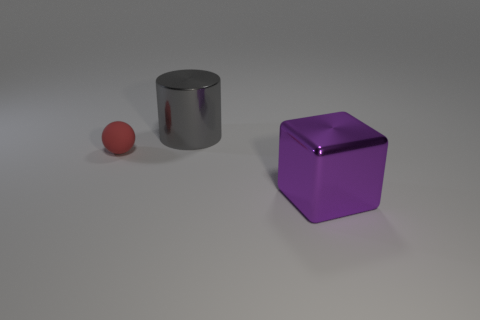Add 2 green matte blocks. How many objects exist? 5 Subtract all cubes. How many objects are left? 2 Add 3 big metallic cylinders. How many big metallic cylinders exist? 4 Subtract 0 yellow cubes. How many objects are left? 3 Subtract all big blue metallic spheres. Subtract all gray metallic things. How many objects are left? 2 Add 3 red matte spheres. How many red matte spheres are left? 4 